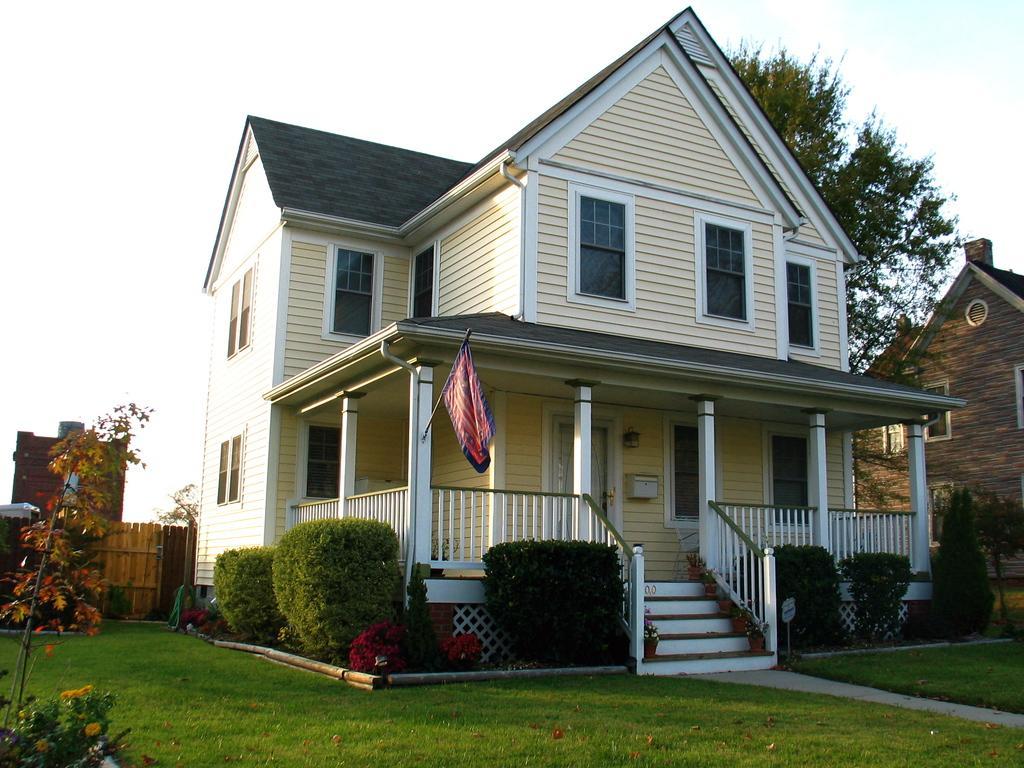How would you summarize this image in a sentence or two? In this image I can see two buildings in cream and brown color, I can also see trees and grass in green color and the sky is in white color. 